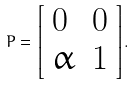Convert formula to latex. <formula><loc_0><loc_0><loc_500><loc_500>P = { \left [ \begin{array} { l l } { 0 } & { 0 } \\ { \alpha } & { 1 } \end{array} \right ] } .</formula> 